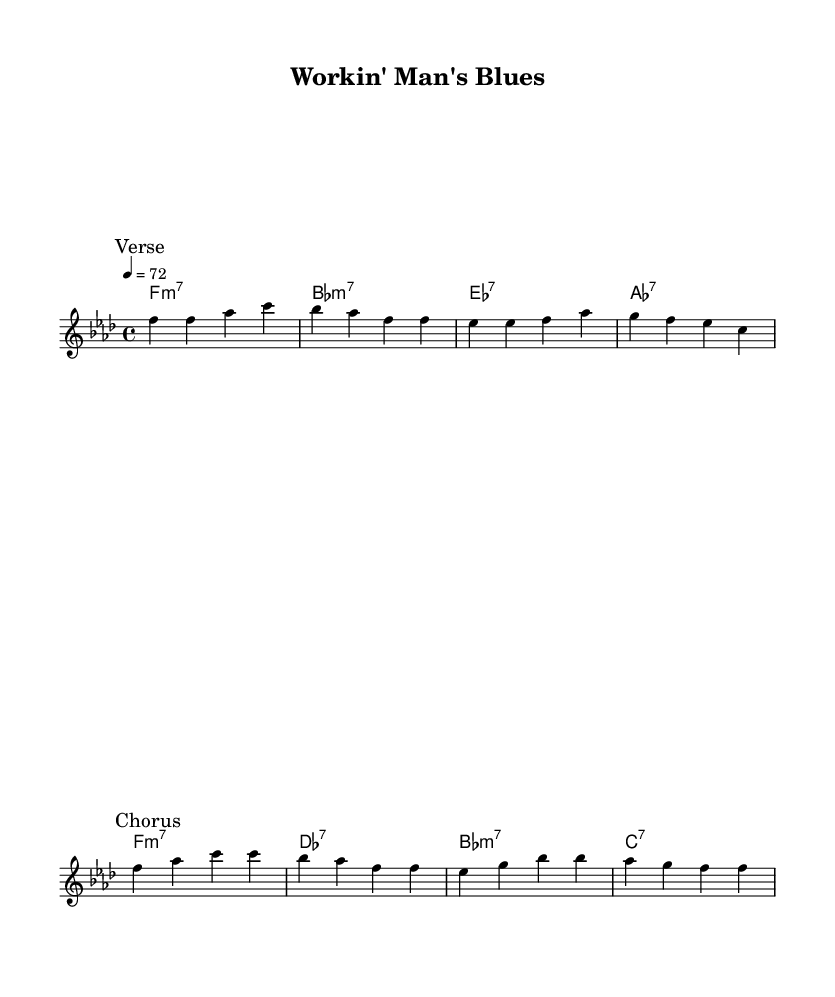What is the key signature of this music? The key signature is indicated by the 'key' directive in the score, which shows that the piece is in F minor, with four flats present in the signature.
Answer: F minor What is the time signature of this music? The time signature is shown at the beginning of the score and is represented by '4/4', indicating there are four beats in each measure and a quarter note gets one beat.
Answer: 4/4 What is the tempo marking of this music? The tempo is indicated by the 'tempo' directive, stating "4 = 72." This indicates that there should be 72 quarter note beats per minute.
Answer: 72 How many measures are in the verse section? By examining the melody section for the verse marked with \mark "Verse," we can count each measure. There are 4 measures in this section.
Answer: 4 What is the first chord played in the harmonies? The first chord is listed under the 'harmonies' section, which shows 'f1:m7' as the first chord played, indicating an F minor 7 chord.
Answer: F minor 7 What musical form does this piece likely use based on the sections presented? The piece has defined sections named 'Verse' and 'Chorus,' which suggests it follows a common structure found in soul music, typically consisting of verses and a recurring chorus.
Answer: Verse and Chorus What theme does the title "Workin' Man's Blues" suggest about the content of the song? The title indicates that the song likely addresses themes of struggle, hardship, and the day-to-day challenges faced by working-class Americans, which is a prominent topic in soul music.
Answer: Working-class struggles 